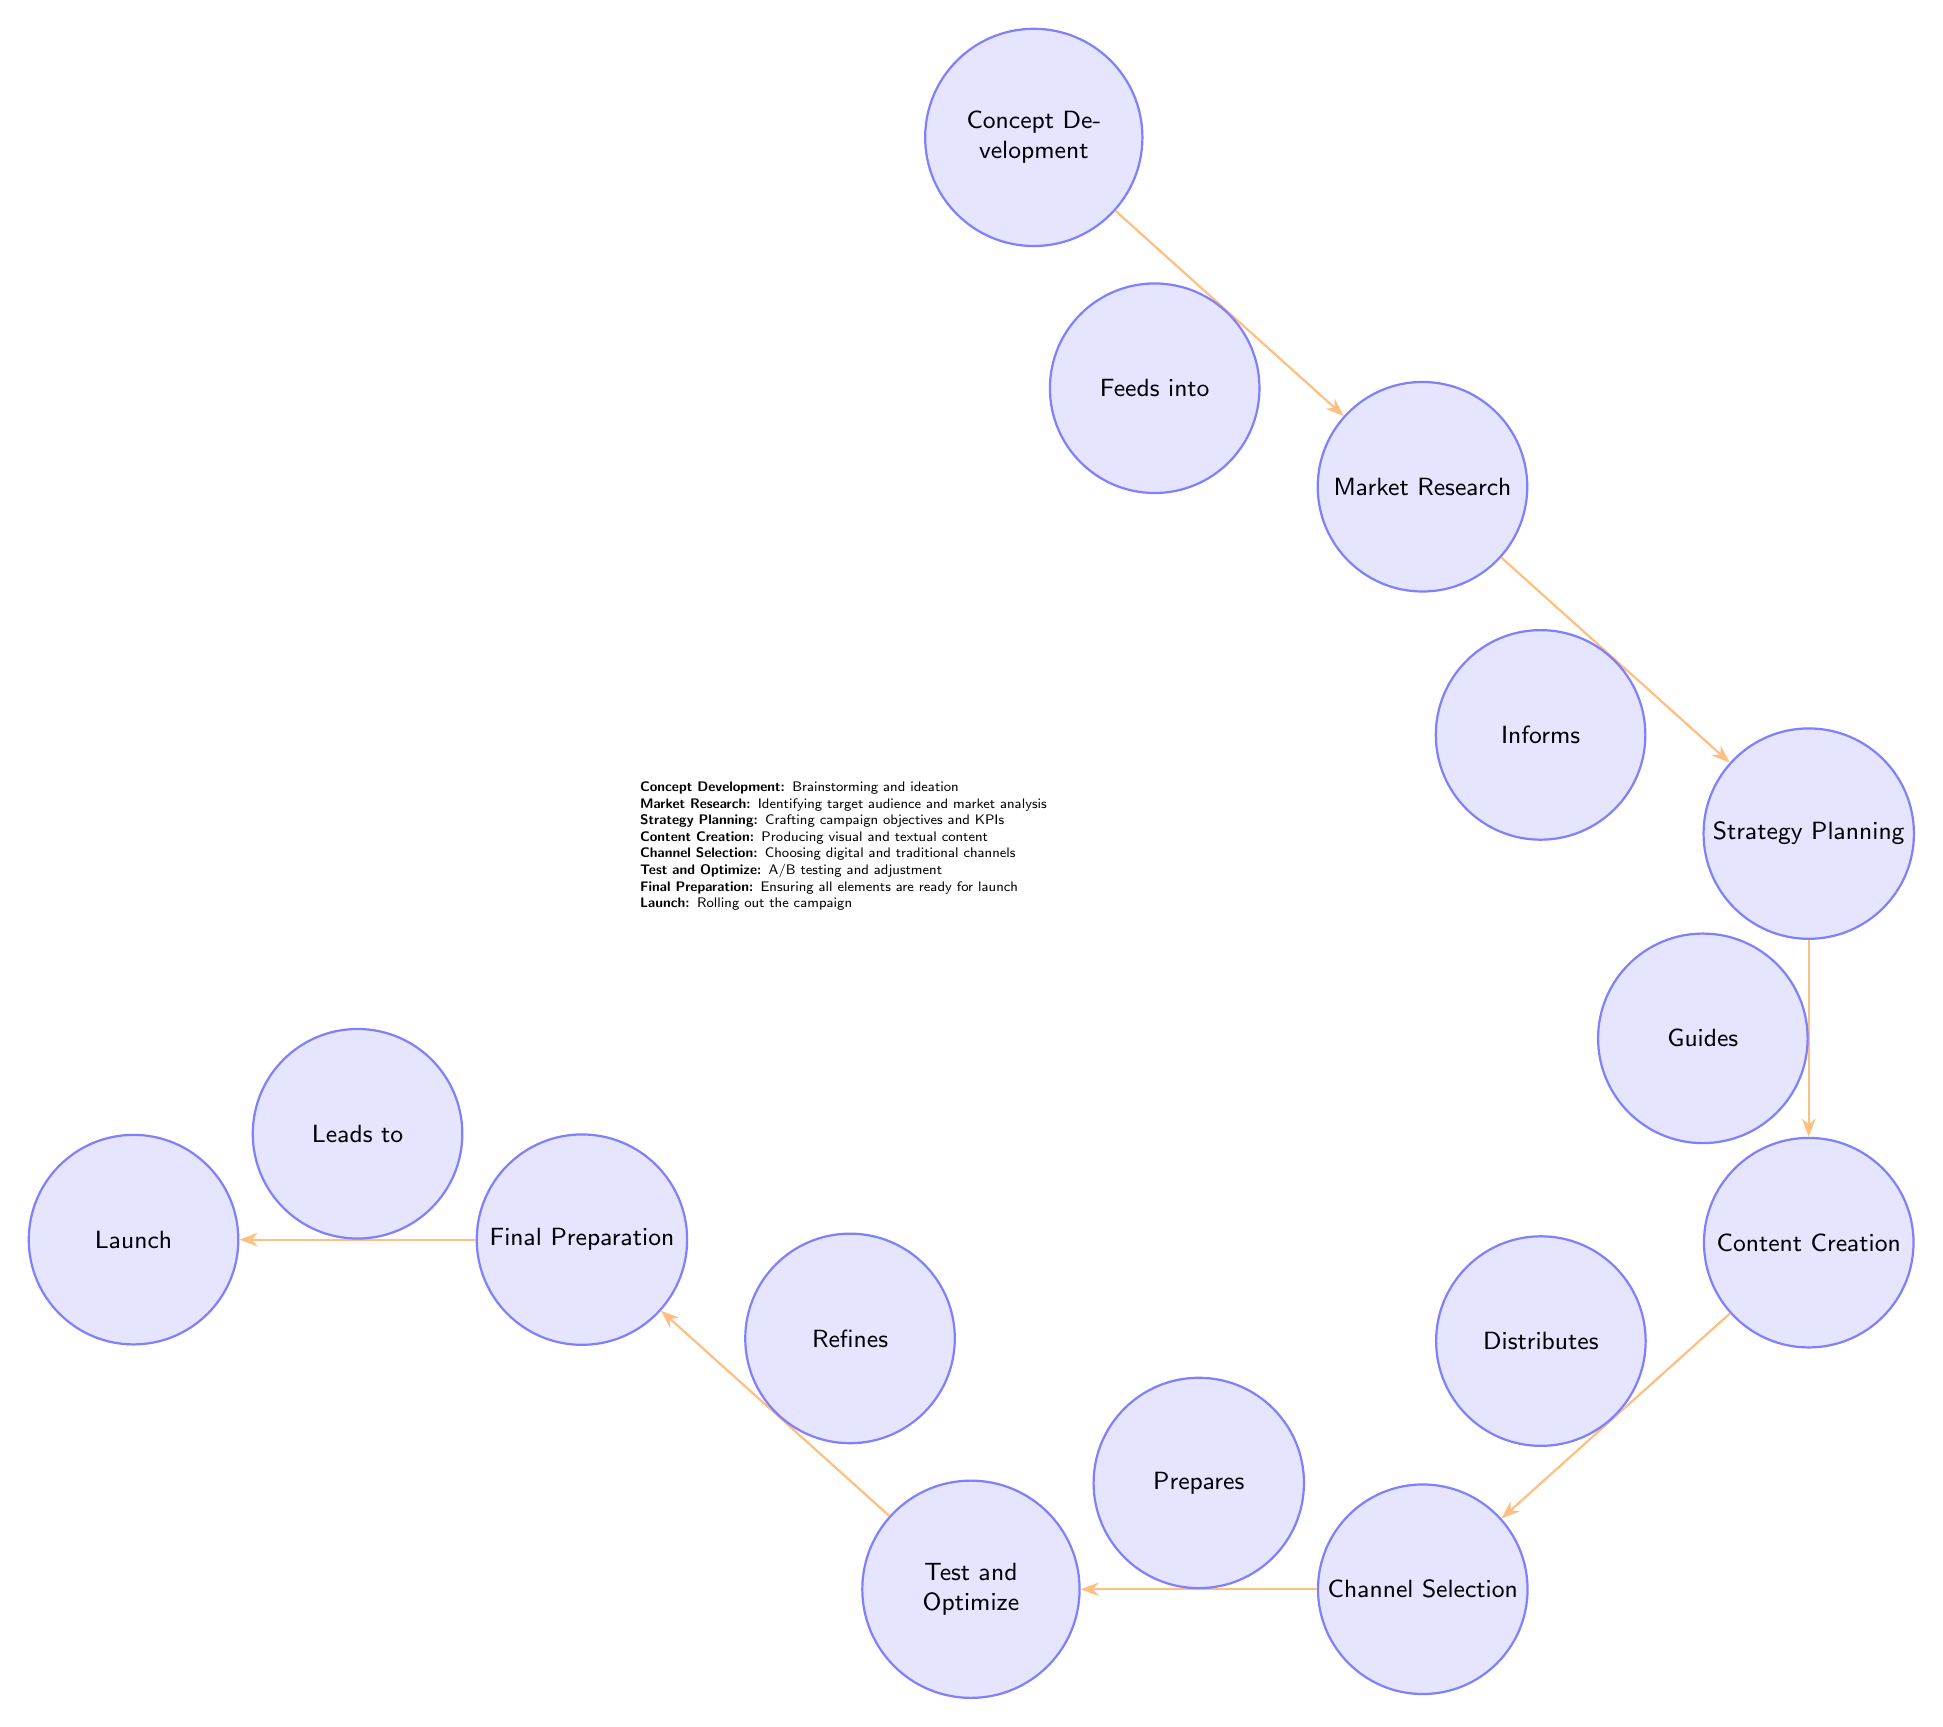What is the first step in the campaign lifecycle? The first step is labeled as "Concept Development." It is represented as the top node in the diagram, indicating where the lifecycle begins.
Answer: Concept Development How many main steps are there in the campaign lifecycle according to the diagram? The diagram includes eight main steps: Concept Development, Market Research, Strategy Planning, Content Creation, Channel Selection, Test and Optimize, Final Preparation, and Launch. Counting each individual step confirms a total of eight.
Answer: 8 What does "Market Research" inform in the lifecycle? "Market Research" directly informs "Strategy Planning," as indicated by the edge between the two nodes that is labeled "Informs." This shows the directional relationship where the output of Market Research is input for Strategy Planning.
Answer: Strategy Planning Which step comes immediately after "Content Creation"? "Channel Selection" is the step that follows "Content Creation" in the diagram, as indicated by the direction of the arrow leading down from Content Creation towards Channel Selection.
Answer: Channel Selection What action does "Test and Optimize" lead to? "Test and Optimize" leads to "Final Preparation," as shown by the arrow connecting these two steps. This indicates that the action taken in Test and Optimize directly influences what occurs in Final Preparation.
Answer: Final Preparation What is the role of "Channel Selection" in the lifecycle? "Channel Selection" is responsible for preparing for the "Test and Optimize" phase, as indicated by the edge labeled "Prepares" that connects these two nodes. This means that decisions made during Channel Selection set the stage for testing.
Answer: Prepares Which step distributes content? The step that distributes content is labeled "Content Creation." The diagram indicates that this step produces content that is then distributed through various channels, emphasizing its role in the overall lifecycle.
Answer: Content Creation What connects "Final Preparation" and "Launch"? The connection between "Final Preparation" and "Launch" is depicted by an arrow labeled "Leads to." This shows that the successful completion of Final Preparation is a prerequisite for the Launch step in the lifecycle.
Answer: Leads to 